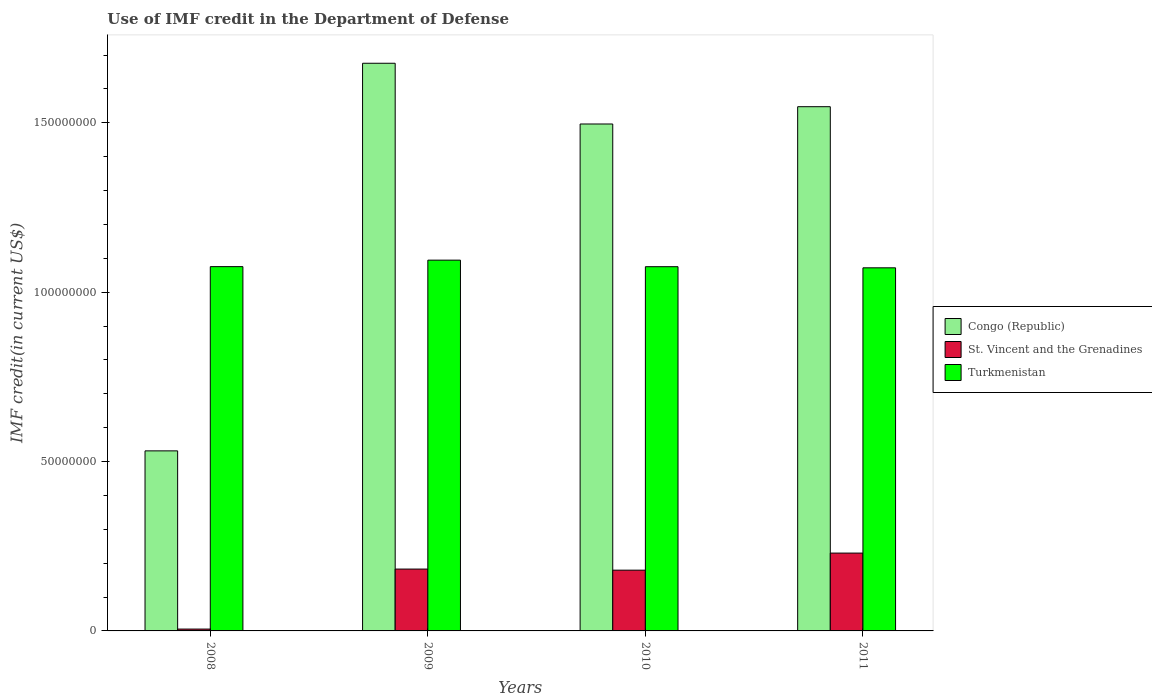How many groups of bars are there?
Your response must be concise. 4. Are the number of bars per tick equal to the number of legend labels?
Offer a very short reply. Yes. Are the number of bars on each tick of the X-axis equal?
Make the answer very short. Yes. What is the label of the 2nd group of bars from the left?
Your answer should be very brief. 2009. In how many cases, is the number of bars for a given year not equal to the number of legend labels?
Offer a very short reply. 0. What is the IMF credit in the Department of Defense in Turkmenistan in 2008?
Keep it short and to the point. 1.08e+08. Across all years, what is the maximum IMF credit in the Department of Defense in St. Vincent and the Grenadines?
Provide a short and direct response. 2.30e+07. Across all years, what is the minimum IMF credit in the Department of Defense in St. Vincent and the Grenadines?
Your answer should be very brief. 5.45e+05. What is the total IMF credit in the Department of Defense in Turkmenistan in the graph?
Offer a terse response. 4.32e+08. What is the difference between the IMF credit in the Department of Defense in Turkmenistan in 2008 and that in 2009?
Keep it short and to the point. -1.91e+06. What is the difference between the IMF credit in the Department of Defense in Turkmenistan in 2011 and the IMF credit in the Department of Defense in St. Vincent and the Grenadines in 2009?
Offer a terse response. 8.89e+07. What is the average IMF credit in the Department of Defense in St. Vincent and the Grenadines per year?
Your response must be concise. 1.49e+07. In the year 2008, what is the difference between the IMF credit in the Department of Defense in Turkmenistan and IMF credit in the Department of Defense in St. Vincent and the Grenadines?
Offer a terse response. 1.07e+08. In how many years, is the IMF credit in the Department of Defense in St. Vincent and the Grenadines greater than 160000000 US$?
Offer a very short reply. 0. What is the ratio of the IMF credit in the Department of Defense in Turkmenistan in 2008 to that in 2009?
Keep it short and to the point. 0.98. Is the IMF credit in the Department of Defense in St. Vincent and the Grenadines in 2010 less than that in 2011?
Offer a terse response. Yes. What is the difference between the highest and the second highest IMF credit in the Department of Defense in St. Vincent and the Grenadines?
Provide a short and direct response. 4.72e+06. What is the difference between the highest and the lowest IMF credit in the Department of Defense in Congo (Republic)?
Keep it short and to the point. 1.14e+08. In how many years, is the IMF credit in the Department of Defense in St. Vincent and the Grenadines greater than the average IMF credit in the Department of Defense in St. Vincent and the Grenadines taken over all years?
Give a very brief answer. 3. Is the sum of the IMF credit in the Department of Defense in Congo (Republic) in 2009 and 2011 greater than the maximum IMF credit in the Department of Defense in St. Vincent and the Grenadines across all years?
Your answer should be compact. Yes. What does the 2nd bar from the left in 2010 represents?
Make the answer very short. St. Vincent and the Grenadines. What does the 3rd bar from the right in 2008 represents?
Provide a succinct answer. Congo (Republic). Is it the case that in every year, the sum of the IMF credit in the Department of Defense in Turkmenistan and IMF credit in the Department of Defense in St. Vincent and the Grenadines is greater than the IMF credit in the Department of Defense in Congo (Republic)?
Ensure brevity in your answer.  No. Does the graph contain any zero values?
Ensure brevity in your answer.  No. What is the title of the graph?
Provide a succinct answer. Use of IMF credit in the Department of Defense. Does "Chile" appear as one of the legend labels in the graph?
Make the answer very short. No. What is the label or title of the X-axis?
Your answer should be very brief. Years. What is the label or title of the Y-axis?
Ensure brevity in your answer.  IMF credit(in current US$). What is the IMF credit(in current US$) of Congo (Republic) in 2008?
Provide a succinct answer. 5.32e+07. What is the IMF credit(in current US$) in St. Vincent and the Grenadines in 2008?
Provide a succinct answer. 5.45e+05. What is the IMF credit(in current US$) in Turkmenistan in 2008?
Offer a terse response. 1.08e+08. What is the IMF credit(in current US$) of Congo (Republic) in 2009?
Keep it short and to the point. 1.68e+08. What is the IMF credit(in current US$) of St. Vincent and the Grenadines in 2009?
Ensure brevity in your answer.  1.83e+07. What is the IMF credit(in current US$) of Turkmenistan in 2009?
Provide a short and direct response. 1.09e+08. What is the IMF credit(in current US$) in Congo (Republic) in 2010?
Keep it short and to the point. 1.50e+08. What is the IMF credit(in current US$) of St. Vincent and the Grenadines in 2010?
Keep it short and to the point. 1.79e+07. What is the IMF credit(in current US$) in Turkmenistan in 2010?
Provide a short and direct response. 1.08e+08. What is the IMF credit(in current US$) in Congo (Republic) in 2011?
Give a very brief answer. 1.55e+08. What is the IMF credit(in current US$) in St. Vincent and the Grenadines in 2011?
Your response must be concise. 2.30e+07. What is the IMF credit(in current US$) of Turkmenistan in 2011?
Your response must be concise. 1.07e+08. Across all years, what is the maximum IMF credit(in current US$) in Congo (Republic)?
Your answer should be very brief. 1.68e+08. Across all years, what is the maximum IMF credit(in current US$) of St. Vincent and the Grenadines?
Your response must be concise. 2.30e+07. Across all years, what is the maximum IMF credit(in current US$) of Turkmenistan?
Keep it short and to the point. 1.09e+08. Across all years, what is the minimum IMF credit(in current US$) of Congo (Republic)?
Your response must be concise. 5.32e+07. Across all years, what is the minimum IMF credit(in current US$) in St. Vincent and the Grenadines?
Offer a very short reply. 5.45e+05. Across all years, what is the minimum IMF credit(in current US$) of Turkmenistan?
Make the answer very short. 1.07e+08. What is the total IMF credit(in current US$) in Congo (Republic) in the graph?
Provide a succinct answer. 5.25e+08. What is the total IMF credit(in current US$) in St. Vincent and the Grenadines in the graph?
Your answer should be very brief. 5.97e+07. What is the total IMF credit(in current US$) in Turkmenistan in the graph?
Your answer should be compact. 4.32e+08. What is the difference between the IMF credit(in current US$) in Congo (Republic) in 2008 and that in 2009?
Make the answer very short. -1.14e+08. What is the difference between the IMF credit(in current US$) in St. Vincent and the Grenadines in 2008 and that in 2009?
Offer a terse response. -1.77e+07. What is the difference between the IMF credit(in current US$) of Turkmenistan in 2008 and that in 2009?
Your answer should be compact. -1.91e+06. What is the difference between the IMF credit(in current US$) of Congo (Republic) in 2008 and that in 2010?
Your response must be concise. -9.65e+07. What is the difference between the IMF credit(in current US$) of St. Vincent and the Grenadines in 2008 and that in 2010?
Provide a short and direct response. -1.74e+07. What is the difference between the IMF credit(in current US$) in Turkmenistan in 2008 and that in 2010?
Provide a short and direct response. 1.70e+04. What is the difference between the IMF credit(in current US$) in Congo (Republic) in 2008 and that in 2011?
Your answer should be very brief. -1.02e+08. What is the difference between the IMF credit(in current US$) in St. Vincent and the Grenadines in 2008 and that in 2011?
Your response must be concise. -2.24e+07. What is the difference between the IMF credit(in current US$) in Turkmenistan in 2008 and that in 2011?
Your response must be concise. 3.49e+05. What is the difference between the IMF credit(in current US$) of Congo (Republic) in 2009 and that in 2010?
Provide a short and direct response. 1.79e+07. What is the difference between the IMF credit(in current US$) in St. Vincent and the Grenadines in 2009 and that in 2010?
Provide a short and direct response. 3.22e+05. What is the difference between the IMF credit(in current US$) of Turkmenistan in 2009 and that in 2010?
Provide a succinct answer. 1.93e+06. What is the difference between the IMF credit(in current US$) of Congo (Republic) in 2009 and that in 2011?
Give a very brief answer. 1.28e+07. What is the difference between the IMF credit(in current US$) of St. Vincent and the Grenadines in 2009 and that in 2011?
Give a very brief answer. -4.72e+06. What is the difference between the IMF credit(in current US$) of Turkmenistan in 2009 and that in 2011?
Provide a succinct answer. 2.26e+06. What is the difference between the IMF credit(in current US$) of Congo (Republic) in 2010 and that in 2011?
Ensure brevity in your answer.  -5.10e+06. What is the difference between the IMF credit(in current US$) of St. Vincent and the Grenadines in 2010 and that in 2011?
Keep it short and to the point. -5.04e+06. What is the difference between the IMF credit(in current US$) of Turkmenistan in 2010 and that in 2011?
Offer a terse response. 3.32e+05. What is the difference between the IMF credit(in current US$) in Congo (Republic) in 2008 and the IMF credit(in current US$) in St. Vincent and the Grenadines in 2009?
Your response must be concise. 3.49e+07. What is the difference between the IMF credit(in current US$) in Congo (Republic) in 2008 and the IMF credit(in current US$) in Turkmenistan in 2009?
Give a very brief answer. -5.63e+07. What is the difference between the IMF credit(in current US$) in St. Vincent and the Grenadines in 2008 and the IMF credit(in current US$) in Turkmenistan in 2009?
Provide a succinct answer. -1.09e+08. What is the difference between the IMF credit(in current US$) in Congo (Republic) in 2008 and the IMF credit(in current US$) in St. Vincent and the Grenadines in 2010?
Your answer should be very brief. 3.52e+07. What is the difference between the IMF credit(in current US$) in Congo (Republic) in 2008 and the IMF credit(in current US$) in Turkmenistan in 2010?
Your answer should be very brief. -5.44e+07. What is the difference between the IMF credit(in current US$) of St. Vincent and the Grenadines in 2008 and the IMF credit(in current US$) of Turkmenistan in 2010?
Your answer should be compact. -1.07e+08. What is the difference between the IMF credit(in current US$) in Congo (Republic) in 2008 and the IMF credit(in current US$) in St. Vincent and the Grenadines in 2011?
Your response must be concise. 3.02e+07. What is the difference between the IMF credit(in current US$) of Congo (Republic) in 2008 and the IMF credit(in current US$) of Turkmenistan in 2011?
Keep it short and to the point. -5.40e+07. What is the difference between the IMF credit(in current US$) of St. Vincent and the Grenadines in 2008 and the IMF credit(in current US$) of Turkmenistan in 2011?
Ensure brevity in your answer.  -1.07e+08. What is the difference between the IMF credit(in current US$) of Congo (Republic) in 2009 and the IMF credit(in current US$) of St. Vincent and the Grenadines in 2010?
Give a very brief answer. 1.50e+08. What is the difference between the IMF credit(in current US$) of Congo (Republic) in 2009 and the IMF credit(in current US$) of Turkmenistan in 2010?
Ensure brevity in your answer.  6.01e+07. What is the difference between the IMF credit(in current US$) of St. Vincent and the Grenadines in 2009 and the IMF credit(in current US$) of Turkmenistan in 2010?
Your response must be concise. -8.93e+07. What is the difference between the IMF credit(in current US$) in Congo (Republic) in 2009 and the IMF credit(in current US$) in St. Vincent and the Grenadines in 2011?
Offer a very short reply. 1.45e+08. What is the difference between the IMF credit(in current US$) in Congo (Republic) in 2009 and the IMF credit(in current US$) in Turkmenistan in 2011?
Your answer should be very brief. 6.04e+07. What is the difference between the IMF credit(in current US$) of St. Vincent and the Grenadines in 2009 and the IMF credit(in current US$) of Turkmenistan in 2011?
Make the answer very short. -8.89e+07. What is the difference between the IMF credit(in current US$) in Congo (Republic) in 2010 and the IMF credit(in current US$) in St. Vincent and the Grenadines in 2011?
Offer a very short reply. 1.27e+08. What is the difference between the IMF credit(in current US$) in Congo (Republic) in 2010 and the IMF credit(in current US$) in Turkmenistan in 2011?
Give a very brief answer. 4.25e+07. What is the difference between the IMF credit(in current US$) of St. Vincent and the Grenadines in 2010 and the IMF credit(in current US$) of Turkmenistan in 2011?
Offer a terse response. -8.93e+07. What is the average IMF credit(in current US$) in Congo (Republic) per year?
Offer a terse response. 1.31e+08. What is the average IMF credit(in current US$) in St. Vincent and the Grenadines per year?
Provide a short and direct response. 1.49e+07. What is the average IMF credit(in current US$) in Turkmenistan per year?
Your answer should be very brief. 1.08e+08. In the year 2008, what is the difference between the IMF credit(in current US$) in Congo (Republic) and IMF credit(in current US$) in St. Vincent and the Grenadines?
Give a very brief answer. 5.26e+07. In the year 2008, what is the difference between the IMF credit(in current US$) of Congo (Republic) and IMF credit(in current US$) of Turkmenistan?
Keep it short and to the point. -5.44e+07. In the year 2008, what is the difference between the IMF credit(in current US$) of St. Vincent and the Grenadines and IMF credit(in current US$) of Turkmenistan?
Offer a very short reply. -1.07e+08. In the year 2009, what is the difference between the IMF credit(in current US$) in Congo (Republic) and IMF credit(in current US$) in St. Vincent and the Grenadines?
Make the answer very short. 1.49e+08. In the year 2009, what is the difference between the IMF credit(in current US$) of Congo (Republic) and IMF credit(in current US$) of Turkmenistan?
Your answer should be compact. 5.81e+07. In the year 2009, what is the difference between the IMF credit(in current US$) of St. Vincent and the Grenadines and IMF credit(in current US$) of Turkmenistan?
Offer a terse response. -9.12e+07. In the year 2010, what is the difference between the IMF credit(in current US$) of Congo (Republic) and IMF credit(in current US$) of St. Vincent and the Grenadines?
Ensure brevity in your answer.  1.32e+08. In the year 2010, what is the difference between the IMF credit(in current US$) in Congo (Republic) and IMF credit(in current US$) in Turkmenistan?
Your answer should be very brief. 4.21e+07. In the year 2010, what is the difference between the IMF credit(in current US$) of St. Vincent and the Grenadines and IMF credit(in current US$) of Turkmenistan?
Offer a very short reply. -8.96e+07. In the year 2011, what is the difference between the IMF credit(in current US$) in Congo (Republic) and IMF credit(in current US$) in St. Vincent and the Grenadines?
Keep it short and to the point. 1.32e+08. In the year 2011, what is the difference between the IMF credit(in current US$) in Congo (Republic) and IMF credit(in current US$) in Turkmenistan?
Keep it short and to the point. 4.76e+07. In the year 2011, what is the difference between the IMF credit(in current US$) in St. Vincent and the Grenadines and IMF credit(in current US$) in Turkmenistan?
Your answer should be compact. -8.42e+07. What is the ratio of the IMF credit(in current US$) of Congo (Republic) in 2008 to that in 2009?
Keep it short and to the point. 0.32. What is the ratio of the IMF credit(in current US$) in St. Vincent and the Grenadines in 2008 to that in 2009?
Give a very brief answer. 0.03. What is the ratio of the IMF credit(in current US$) of Turkmenistan in 2008 to that in 2009?
Provide a short and direct response. 0.98. What is the ratio of the IMF credit(in current US$) of Congo (Republic) in 2008 to that in 2010?
Give a very brief answer. 0.36. What is the ratio of the IMF credit(in current US$) of St. Vincent and the Grenadines in 2008 to that in 2010?
Provide a short and direct response. 0.03. What is the ratio of the IMF credit(in current US$) of Congo (Republic) in 2008 to that in 2011?
Your answer should be very brief. 0.34. What is the ratio of the IMF credit(in current US$) of St. Vincent and the Grenadines in 2008 to that in 2011?
Provide a succinct answer. 0.02. What is the ratio of the IMF credit(in current US$) in Turkmenistan in 2008 to that in 2011?
Offer a very short reply. 1. What is the ratio of the IMF credit(in current US$) of Congo (Republic) in 2009 to that in 2010?
Your answer should be compact. 1.12. What is the ratio of the IMF credit(in current US$) in St. Vincent and the Grenadines in 2009 to that in 2010?
Offer a terse response. 1.02. What is the ratio of the IMF credit(in current US$) in Congo (Republic) in 2009 to that in 2011?
Provide a succinct answer. 1.08. What is the ratio of the IMF credit(in current US$) of St. Vincent and the Grenadines in 2009 to that in 2011?
Keep it short and to the point. 0.79. What is the ratio of the IMF credit(in current US$) of Turkmenistan in 2009 to that in 2011?
Ensure brevity in your answer.  1.02. What is the ratio of the IMF credit(in current US$) in Congo (Republic) in 2010 to that in 2011?
Offer a terse response. 0.97. What is the ratio of the IMF credit(in current US$) in St. Vincent and the Grenadines in 2010 to that in 2011?
Keep it short and to the point. 0.78. What is the ratio of the IMF credit(in current US$) in Turkmenistan in 2010 to that in 2011?
Make the answer very short. 1. What is the difference between the highest and the second highest IMF credit(in current US$) in Congo (Republic)?
Your response must be concise. 1.28e+07. What is the difference between the highest and the second highest IMF credit(in current US$) of St. Vincent and the Grenadines?
Your answer should be very brief. 4.72e+06. What is the difference between the highest and the second highest IMF credit(in current US$) of Turkmenistan?
Make the answer very short. 1.91e+06. What is the difference between the highest and the lowest IMF credit(in current US$) in Congo (Republic)?
Give a very brief answer. 1.14e+08. What is the difference between the highest and the lowest IMF credit(in current US$) of St. Vincent and the Grenadines?
Give a very brief answer. 2.24e+07. What is the difference between the highest and the lowest IMF credit(in current US$) of Turkmenistan?
Your answer should be very brief. 2.26e+06. 